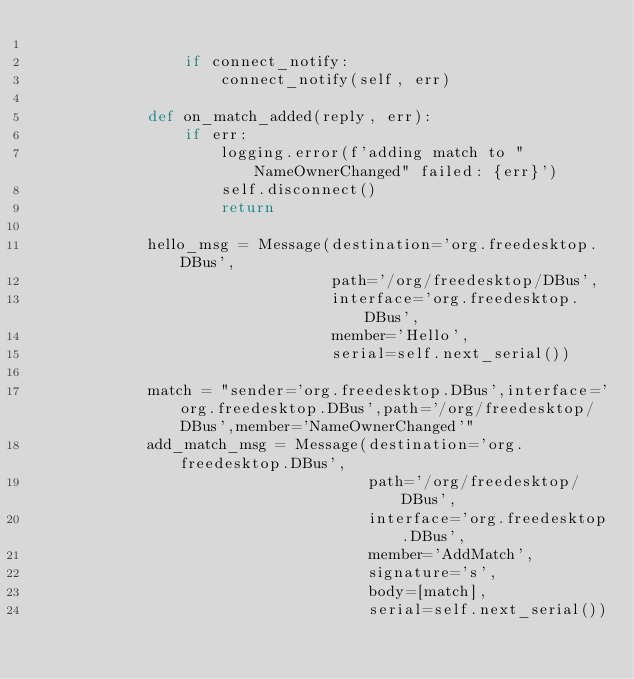<code> <loc_0><loc_0><loc_500><loc_500><_Python_>
                if connect_notify:
                    connect_notify(self, err)

            def on_match_added(reply, err):
                if err:
                    logging.error(f'adding match to "NameOwnerChanged" failed: {err}')
                    self.disconnect()
                    return

            hello_msg = Message(destination='org.freedesktop.DBus',
                                path='/org/freedesktop/DBus',
                                interface='org.freedesktop.DBus',
                                member='Hello',
                                serial=self.next_serial())

            match = "sender='org.freedesktop.DBus',interface='org.freedesktop.DBus',path='/org/freedesktop/DBus',member='NameOwnerChanged'"
            add_match_msg = Message(destination='org.freedesktop.DBus',
                                    path='/org/freedesktop/DBus',
                                    interface='org.freedesktop.DBus',
                                    member='AddMatch',
                                    signature='s',
                                    body=[match],
                                    serial=self.next_serial())
</code> 